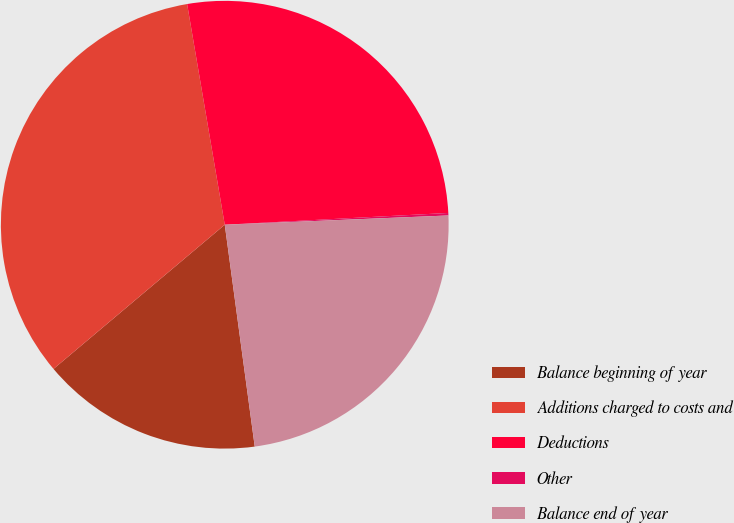Convert chart. <chart><loc_0><loc_0><loc_500><loc_500><pie_chart><fcel>Balance beginning of year<fcel>Additions charged to costs and<fcel>Deductions<fcel>Other<fcel>Balance end of year<nl><fcel>16.0%<fcel>33.45%<fcel>26.85%<fcel>0.18%<fcel>23.52%<nl></chart> 